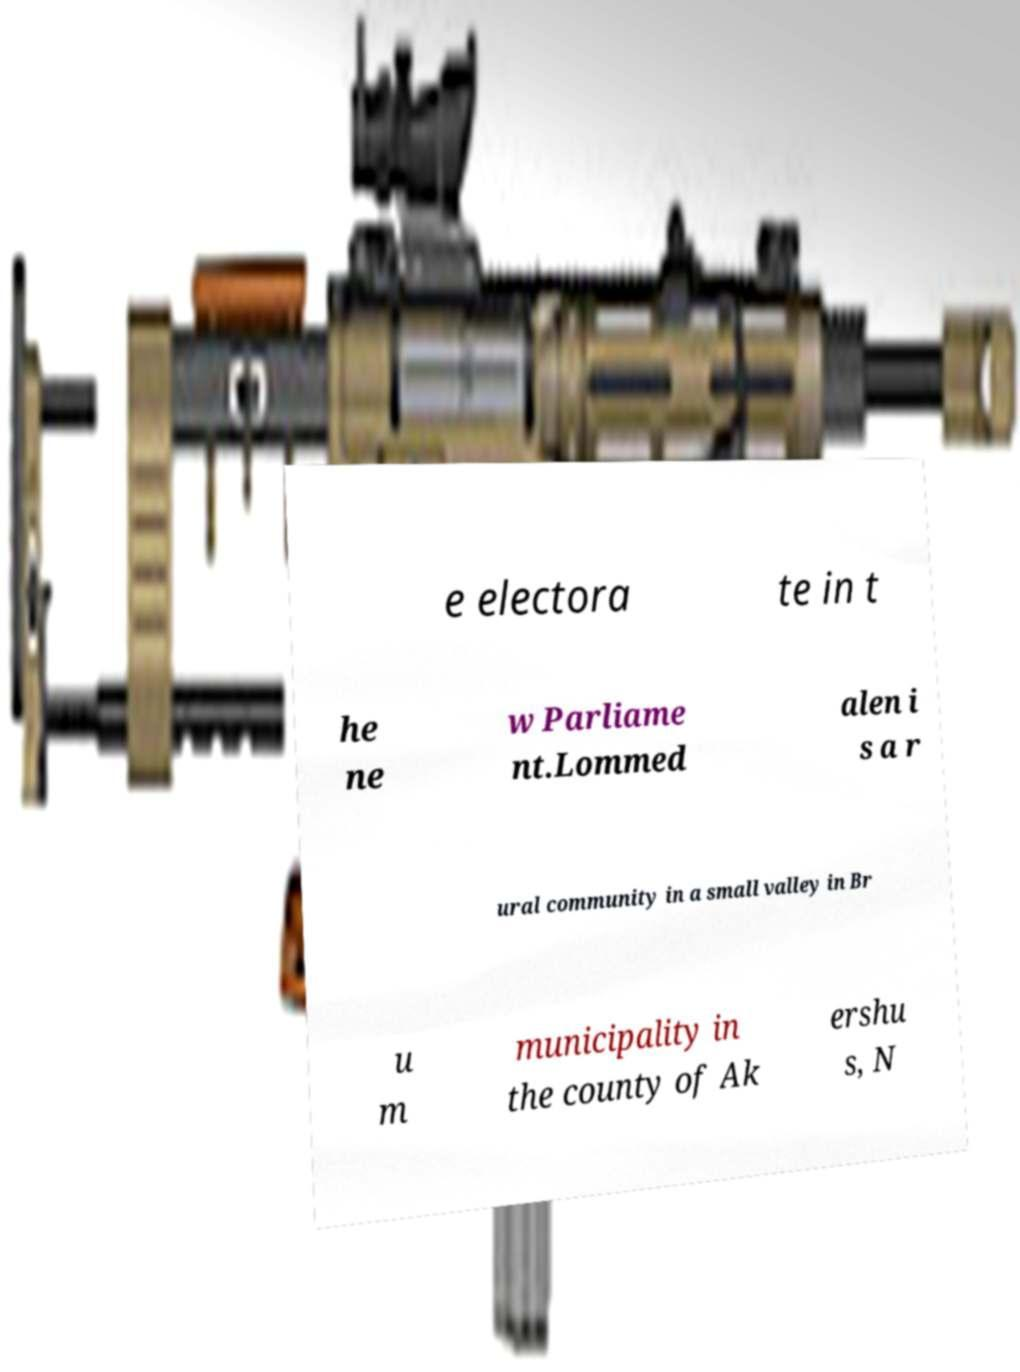Can you read and provide the text displayed in the image?This photo seems to have some interesting text. Can you extract and type it out for me? e electora te in t he ne w Parliame nt.Lommed alen i s a r ural community in a small valley in Br u m municipality in the county of Ak ershu s, N 